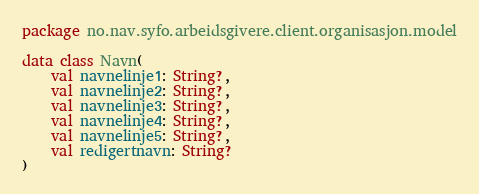Convert code to text. <code><loc_0><loc_0><loc_500><loc_500><_Kotlin_>package no.nav.syfo.arbeidsgivere.client.organisasjon.model

data class Navn(
    val navnelinje1: String?,
    val navnelinje2: String?,
    val navnelinje3: String?,
    val navnelinje4: String?,
    val navnelinje5: String?,
    val redigertnavn: String?
)
</code> 